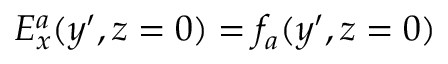Convert formula to latex. <formula><loc_0><loc_0><loc_500><loc_500>E _ { x } ^ { a } ( y ^ { \prime } , z = 0 ) = f _ { a } ( y ^ { \prime } , z = 0 )</formula> 